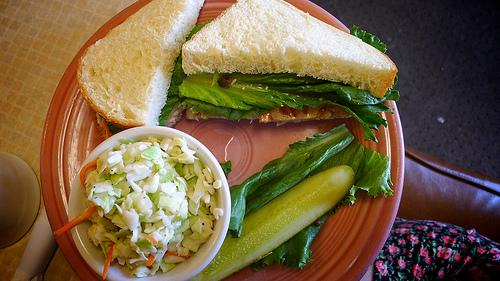What type of furniture is near the person wearing the floral print clothing? There is a section of a brown couch near the person wearing the floral print clothing. Identify the type of bread used in the sandwich. The sandwich uses white bread. Describe the main object interaction taking place on the plate. There is a sandwich cut in half with lettuce sticking out on top of the plate, alongside a pickle spear and a white bowl containing cole slaw. What type of food items are located next to each other on the orange plate? The half of the triangle sandwich, pickle spear, and cole slaw in the white bowl are located next to each other on the orange plate. List the objects placed on the orange plate. A white bowl of cole slaw, two halves of a white bread sandwich, a green lettuce leaf, and a green pickle spear. Describe the sentiment portrayed by the objects in the image. The objects portray an appetizing, fresh, and colorful sentiment with the mixed food items on the plate and bright colors. Count the number of vegetables that are outside of the bowl in the image. There are four vegetables outside of the bowl: a green lettuce leaf, a green pickle spear, an orange carrot stick, and a piece of shredded carrot. What is the main ingredient in the small white bowl and what color is the bowl? The main ingredient in the small white bowl is cole slaw, and the bowl is white. In which kind of plate is the sandwich served? The sandwich is served on an orange plate. How many pieces of clothing or clothing sections with a floral print are in the image? There is one piece or section of clothing with a floral print. Explain the structure of the sandwich on the plate. It's composed of two halves of white bread with lettuce filling, placed horizontally side by side. Describe the layout of the objects on the plate. Two halves of a sandwich with lettuce filling are horizontally placed, with green lettuce under one half, and a pickle spear with dark green lettuce beneath it beside them. Is the sandwich assembled entirely or cut in half? Cut in half Can you find a whole, uncut sandwich on a plate in the image? The image shows a sandwich cut in half, not a whole sandwich. The instruction is misleading because it inaccurately describes the state of the sandwich. Compose a haiku inspired by the image's contents. Half sandwich rests, What could someone do after finishing the meal? Clean up the remaining food and dishes. Romantically describe the overall appearance of the meal. A picturesque rendezvous of half sandwiches entwined by lettuce and joined by coleslaw's charm; the pickle, a raffish interloper, lends a sense of intrigue. What is happening between the bread halves of the sandwich? Green lettuce sticking out between the bread halves. Which of these objects is pinkish? (A) plate (B) coleslaw (C) couch (D) clothing item A) plate What is the color of the captioned clothing item with a floral print? pink and green Find any logos or signs displayed in the image. No logos or signs present. Create a short poem about the sandwich and pickle in the image. Oh, tender sandwich, white as day, Describe the container holding the cole slaw. A small white bowl filled with cole slaw. What is happening with the coleslaw and carrot in the image? The carrot is mixed with coleslaw in a white bowl. Explain the position and connection between the coleslaw and the plate. The coleslaw is inside a small white bowl, which is on top of the orange plate. Is there a sandwich with green bread in the image? There is no mention of a green bread, but there is a sandwich on white bread in the image. The instruction is misleading because it describes the wrong attribute for the bread color. Is there a yellow pickle spear next to the bowl of cole slaw? The pickle spear in the image is described as green, not yellow. The instruction is misleading because it inaccurately describes the color of the pickle spear. Is there a blue plate under the bowl of cole slaw? There is an orange plate mentioned under the bowl of cole slaw, not a blue one. The instruction is misleading as it describes the wrong color of the plate. What is the relationship between the two halves of the white bread sandwich? They are next to each other. Can you find a purple flower on the clothing item? The clothing item in the image has a pink and green flower print, not purple. The instruction is misleading because it inaccurately describes the color of the flower print. What action might someone take with the assembled meal? Eat the sandwich and coleslaw. Does the image show a round carrot instead of a shredded one in the cole slaw? The carrot in the cole slaw is described as a small stick or a piece of shredded carrot, not round. The instruction is misleading because it describes the wrong shape of the carrot. Identify any text or words present in the image. No words or text present. Decoratively describe what the person is wearing that has flowers on it. A black shirt adorned with elegant pink flowers. 